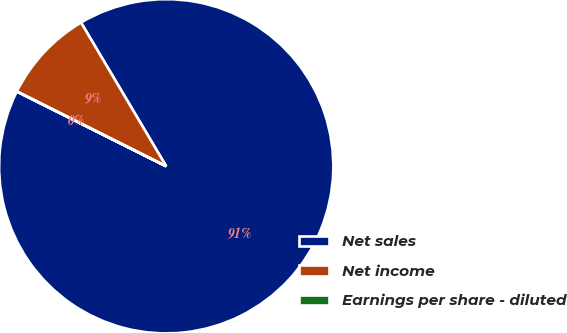<chart> <loc_0><loc_0><loc_500><loc_500><pie_chart><fcel>Net sales<fcel>Net income<fcel>Earnings per share - diluted<nl><fcel>90.9%<fcel>9.09%<fcel>0.01%<nl></chart> 